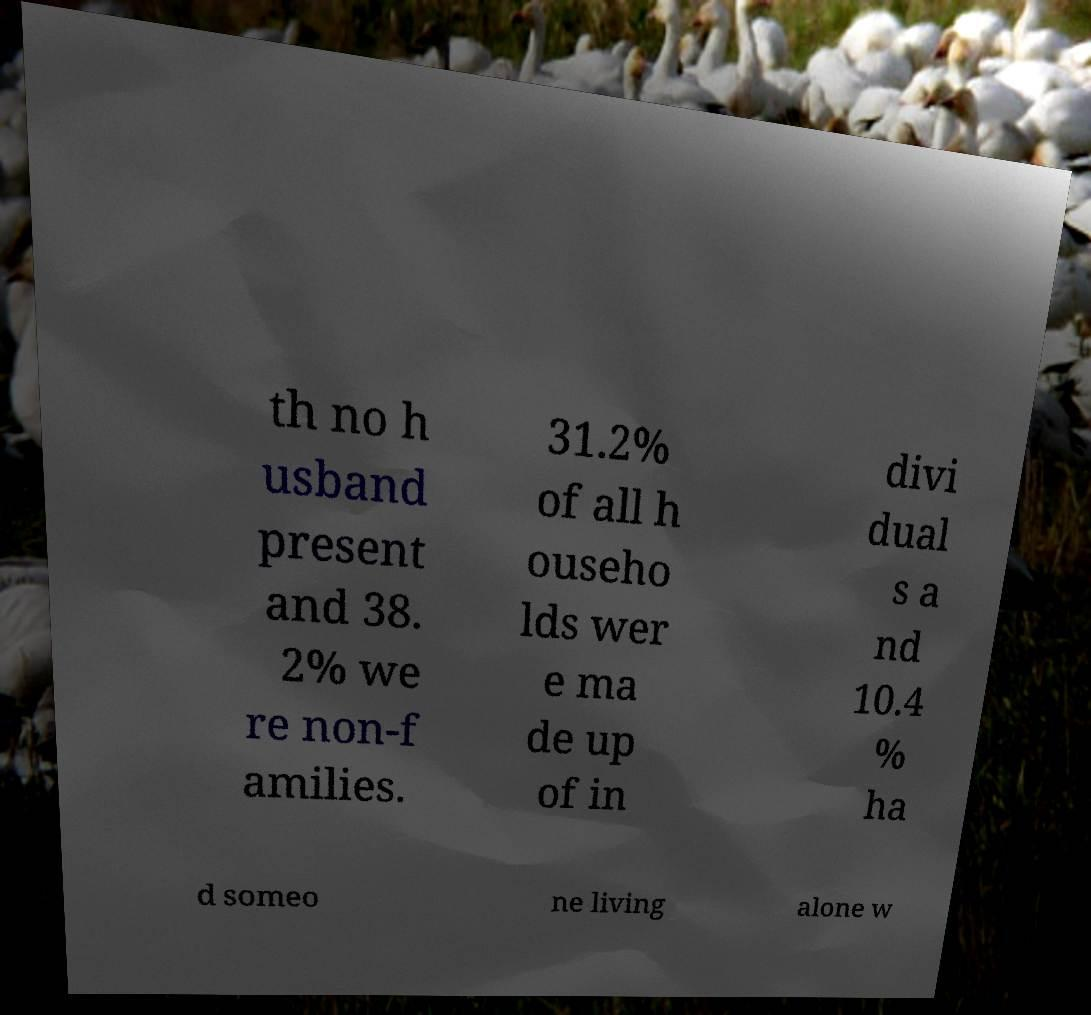There's text embedded in this image that I need extracted. Can you transcribe it verbatim? th no h usband present and 38. 2% we re non-f amilies. 31.2% of all h ouseho lds wer e ma de up of in divi dual s a nd 10.4 % ha d someo ne living alone w 